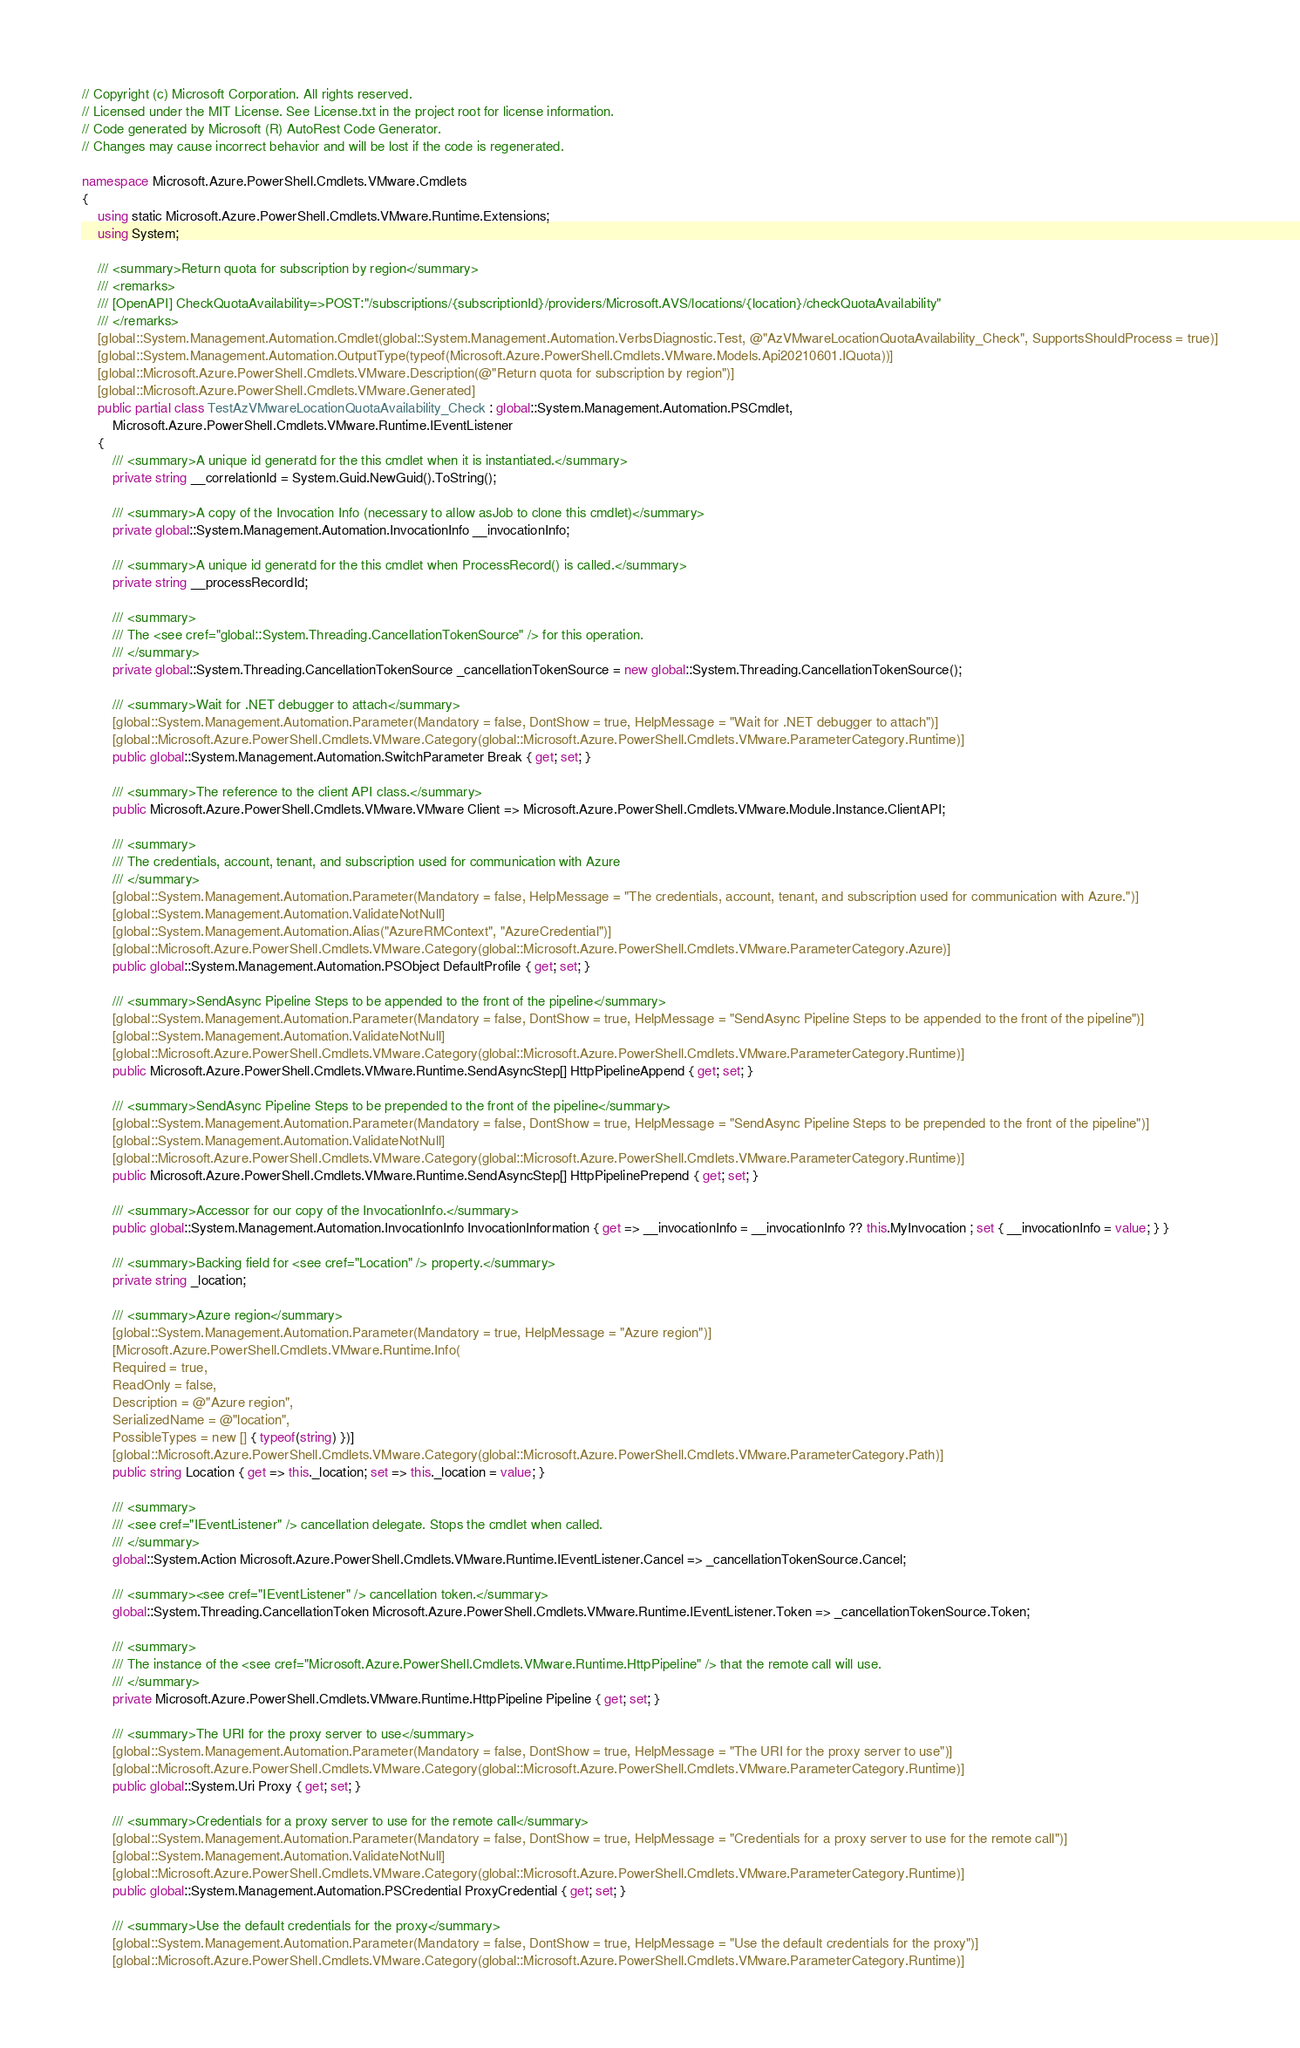Convert code to text. <code><loc_0><loc_0><loc_500><loc_500><_C#_>// Copyright (c) Microsoft Corporation. All rights reserved.
// Licensed under the MIT License. See License.txt in the project root for license information.
// Code generated by Microsoft (R) AutoRest Code Generator.
// Changes may cause incorrect behavior and will be lost if the code is regenerated.

namespace Microsoft.Azure.PowerShell.Cmdlets.VMware.Cmdlets
{
    using static Microsoft.Azure.PowerShell.Cmdlets.VMware.Runtime.Extensions;
    using System;

    /// <summary>Return quota for subscription by region</summary>
    /// <remarks>
    /// [OpenAPI] CheckQuotaAvailability=>POST:"/subscriptions/{subscriptionId}/providers/Microsoft.AVS/locations/{location}/checkQuotaAvailability"
    /// </remarks>
    [global::System.Management.Automation.Cmdlet(global::System.Management.Automation.VerbsDiagnostic.Test, @"AzVMwareLocationQuotaAvailability_Check", SupportsShouldProcess = true)]
    [global::System.Management.Automation.OutputType(typeof(Microsoft.Azure.PowerShell.Cmdlets.VMware.Models.Api20210601.IQuota))]
    [global::Microsoft.Azure.PowerShell.Cmdlets.VMware.Description(@"Return quota for subscription by region")]
    [global::Microsoft.Azure.PowerShell.Cmdlets.VMware.Generated]
    public partial class TestAzVMwareLocationQuotaAvailability_Check : global::System.Management.Automation.PSCmdlet,
        Microsoft.Azure.PowerShell.Cmdlets.VMware.Runtime.IEventListener
    {
        /// <summary>A unique id generatd for the this cmdlet when it is instantiated.</summary>
        private string __correlationId = System.Guid.NewGuid().ToString();

        /// <summary>A copy of the Invocation Info (necessary to allow asJob to clone this cmdlet)</summary>
        private global::System.Management.Automation.InvocationInfo __invocationInfo;

        /// <summary>A unique id generatd for the this cmdlet when ProcessRecord() is called.</summary>
        private string __processRecordId;

        /// <summary>
        /// The <see cref="global::System.Threading.CancellationTokenSource" /> for this operation.
        /// </summary>
        private global::System.Threading.CancellationTokenSource _cancellationTokenSource = new global::System.Threading.CancellationTokenSource();

        /// <summary>Wait for .NET debugger to attach</summary>
        [global::System.Management.Automation.Parameter(Mandatory = false, DontShow = true, HelpMessage = "Wait for .NET debugger to attach")]
        [global::Microsoft.Azure.PowerShell.Cmdlets.VMware.Category(global::Microsoft.Azure.PowerShell.Cmdlets.VMware.ParameterCategory.Runtime)]
        public global::System.Management.Automation.SwitchParameter Break { get; set; }

        /// <summary>The reference to the client API class.</summary>
        public Microsoft.Azure.PowerShell.Cmdlets.VMware.VMware Client => Microsoft.Azure.PowerShell.Cmdlets.VMware.Module.Instance.ClientAPI;

        /// <summary>
        /// The credentials, account, tenant, and subscription used for communication with Azure
        /// </summary>
        [global::System.Management.Automation.Parameter(Mandatory = false, HelpMessage = "The credentials, account, tenant, and subscription used for communication with Azure.")]
        [global::System.Management.Automation.ValidateNotNull]
        [global::System.Management.Automation.Alias("AzureRMContext", "AzureCredential")]
        [global::Microsoft.Azure.PowerShell.Cmdlets.VMware.Category(global::Microsoft.Azure.PowerShell.Cmdlets.VMware.ParameterCategory.Azure)]
        public global::System.Management.Automation.PSObject DefaultProfile { get; set; }

        /// <summary>SendAsync Pipeline Steps to be appended to the front of the pipeline</summary>
        [global::System.Management.Automation.Parameter(Mandatory = false, DontShow = true, HelpMessage = "SendAsync Pipeline Steps to be appended to the front of the pipeline")]
        [global::System.Management.Automation.ValidateNotNull]
        [global::Microsoft.Azure.PowerShell.Cmdlets.VMware.Category(global::Microsoft.Azure.PowerShell.Cmdlets.VMware.ParameterCategory.Runtime)]
        public Microsoft.Azure.PowerShell.Cmdlets.VMware.Runtime.SendAsyncStep[] HttpPipelineAppend { get; set; }

        /// <summary>SendAsync Pipeline Steps to be prepended to the front of the pipeline</summary>
        [global::System.Management.Automation.Parameter(Mandatory = false, DontShow = true, HelpMessage = "SendAsync Pipeline Steps to be prepended to the front of the pipeline")]
        [global::System.Management.Automation.ValidateNotNull]
        [global::Microsoft.Azure.PowerShell.Cmdlets.VMware.Category(global::Microsoft.Azure.PowerShell.Cmdlets.VMware.ParameterCategory.Runtime)]
        public Microsoft.Azure.PowerShell.Cmdlets.VMware.Runtime.SendAsyncStep[] HttpPipelinePrepend { get; set; }

        /// <summary>Accessor for our copy of the InvocationInfo.</summary>
        public global::System.Management.Automation.InvocationInfo InvocationInformation { get => __invocationInfo = __invocationInfo ?? this.MyInvocation ; set { __invocationInfo = value; } }

        /// <summary>Backing field for <see cref="Location" /> property.</summary>
        private string _location;

        /// <summary>Azure region</summary>
        [global::System.Management.Automation.Parameter(Mandatory = true, HelpMessage = "Azure region")]
        [Microsoft.Azure.PowerShell.Cmdlets.VMware.Runtime.Info(
        Required = true,
        ReadOnly = false,
        Description = @"Azure region",
        SerializedName = @"location",
        PossibleTypes = new [] { typeof(string) })]
        [global::Microsoft.Azure.PowerShell.Cmdlets.VMware.Category(global::Microsoft.Azure.PowerShell.Cmdlets.VMware.ParameterCategory.Path)]
        public string Location { get => this._location; set => this._location = value; }

        /// <summary>
        /// <see cref="IEventListener" /> cancellation delegate. Stops the cmdlet when called.
        /// </summary>
        global::System.Action Microsoft.Azure.PowerShell.Cmdlets.VMware.Runtime.IEventListener.Cancel => _cancellationTokenSource.Cancel;

        /// <summary><see cref="IEventListener" /> cancellation token.</summary>
        global::System.Threading.CancellationToken Microsoft.Azure.PowerShell.Cmdlets.VMware.Runtime.IEventListener.Token => _cancellationTokenSource.Token;

        /// <summary>
        /// The instance of the <see cref="Microsoft.Azure.PowerShell.Cmdlets.VMware.Runtime.HttpPipeline" /> that the remote call will use.
        /// </summary>
        private Microsoft.Azure.PowerShell.Cmdlets.VMware.Runtime.HttpPipeline Pipeline { get; set; }

        /// <summary>The URI for the proxy server to use</summary>
        [global::System.Management.Automation.Parameter(Mandatory = false, DontShow = true, HelpMessage = "The URI for the proxy server to use")]
        [global::Microsoft.Azure.PowerShell.Cmdlets.VMware.Category(global::Microsoft.Azure.PowerShell.Cmdlets.VMware.ParameterCategory.Runtime)]
        public global::System.Uri Proxy { get; set; }

        /// <summary>Credentials for a proxy server to use for the remote call</summary>
        [global::System.Management.Automation.Parameter(Mandatory = false, DontShow = true, HelpMessage = "Credentials for a proxy server to use for the remote call")]
        [global::System.Management.Automation.ValidateNotNull]
        [global::Microsoft.Azure.PowerShell.Cmdlets.VMware.Category(global::Microsoft.Azure.PowerShell.Cmdlets.VMware.ParameterCategory.Runtime)]
        public global::System.Management.Automation.PSCredential ProxyCredential { get; set; }

        /// <summary>Use the default credentials for the proxy</summary>
        [global::System.Management.Automation.Parameter(Mandatory = false, DontShow = true, HelpMessage = "Use the default credentials for the proxy")]
        [global::Microsoft.Azure.PowerShell.Cmdlets.VMware.Category(global::Microsoft.Azure.PowerShell.Cmdlets.VMware.ParameterCategory.Runtime)]</code> 